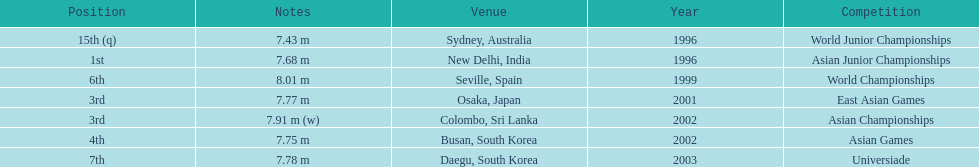In what setting did he attain the top spot? New Delhi, India. 